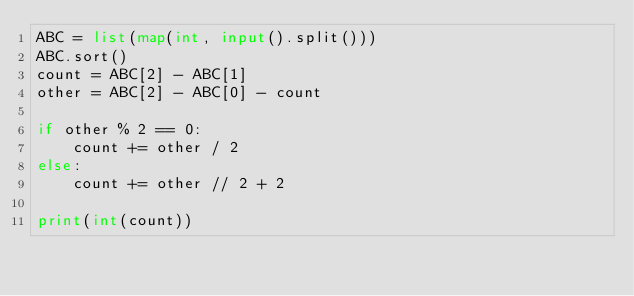<code> <loc_0><loc_0><loc_500><loc_500><_Python_>ABC = list(map(int, input().split()))
ABC.sort()
count = ABC[2] - ABC[1]
other = ABC[2] - ABC[0] - count

if other % 2 == 0:
    count += other / 2
else:
    count += other // 2 + 2

print(int(count))</code> 